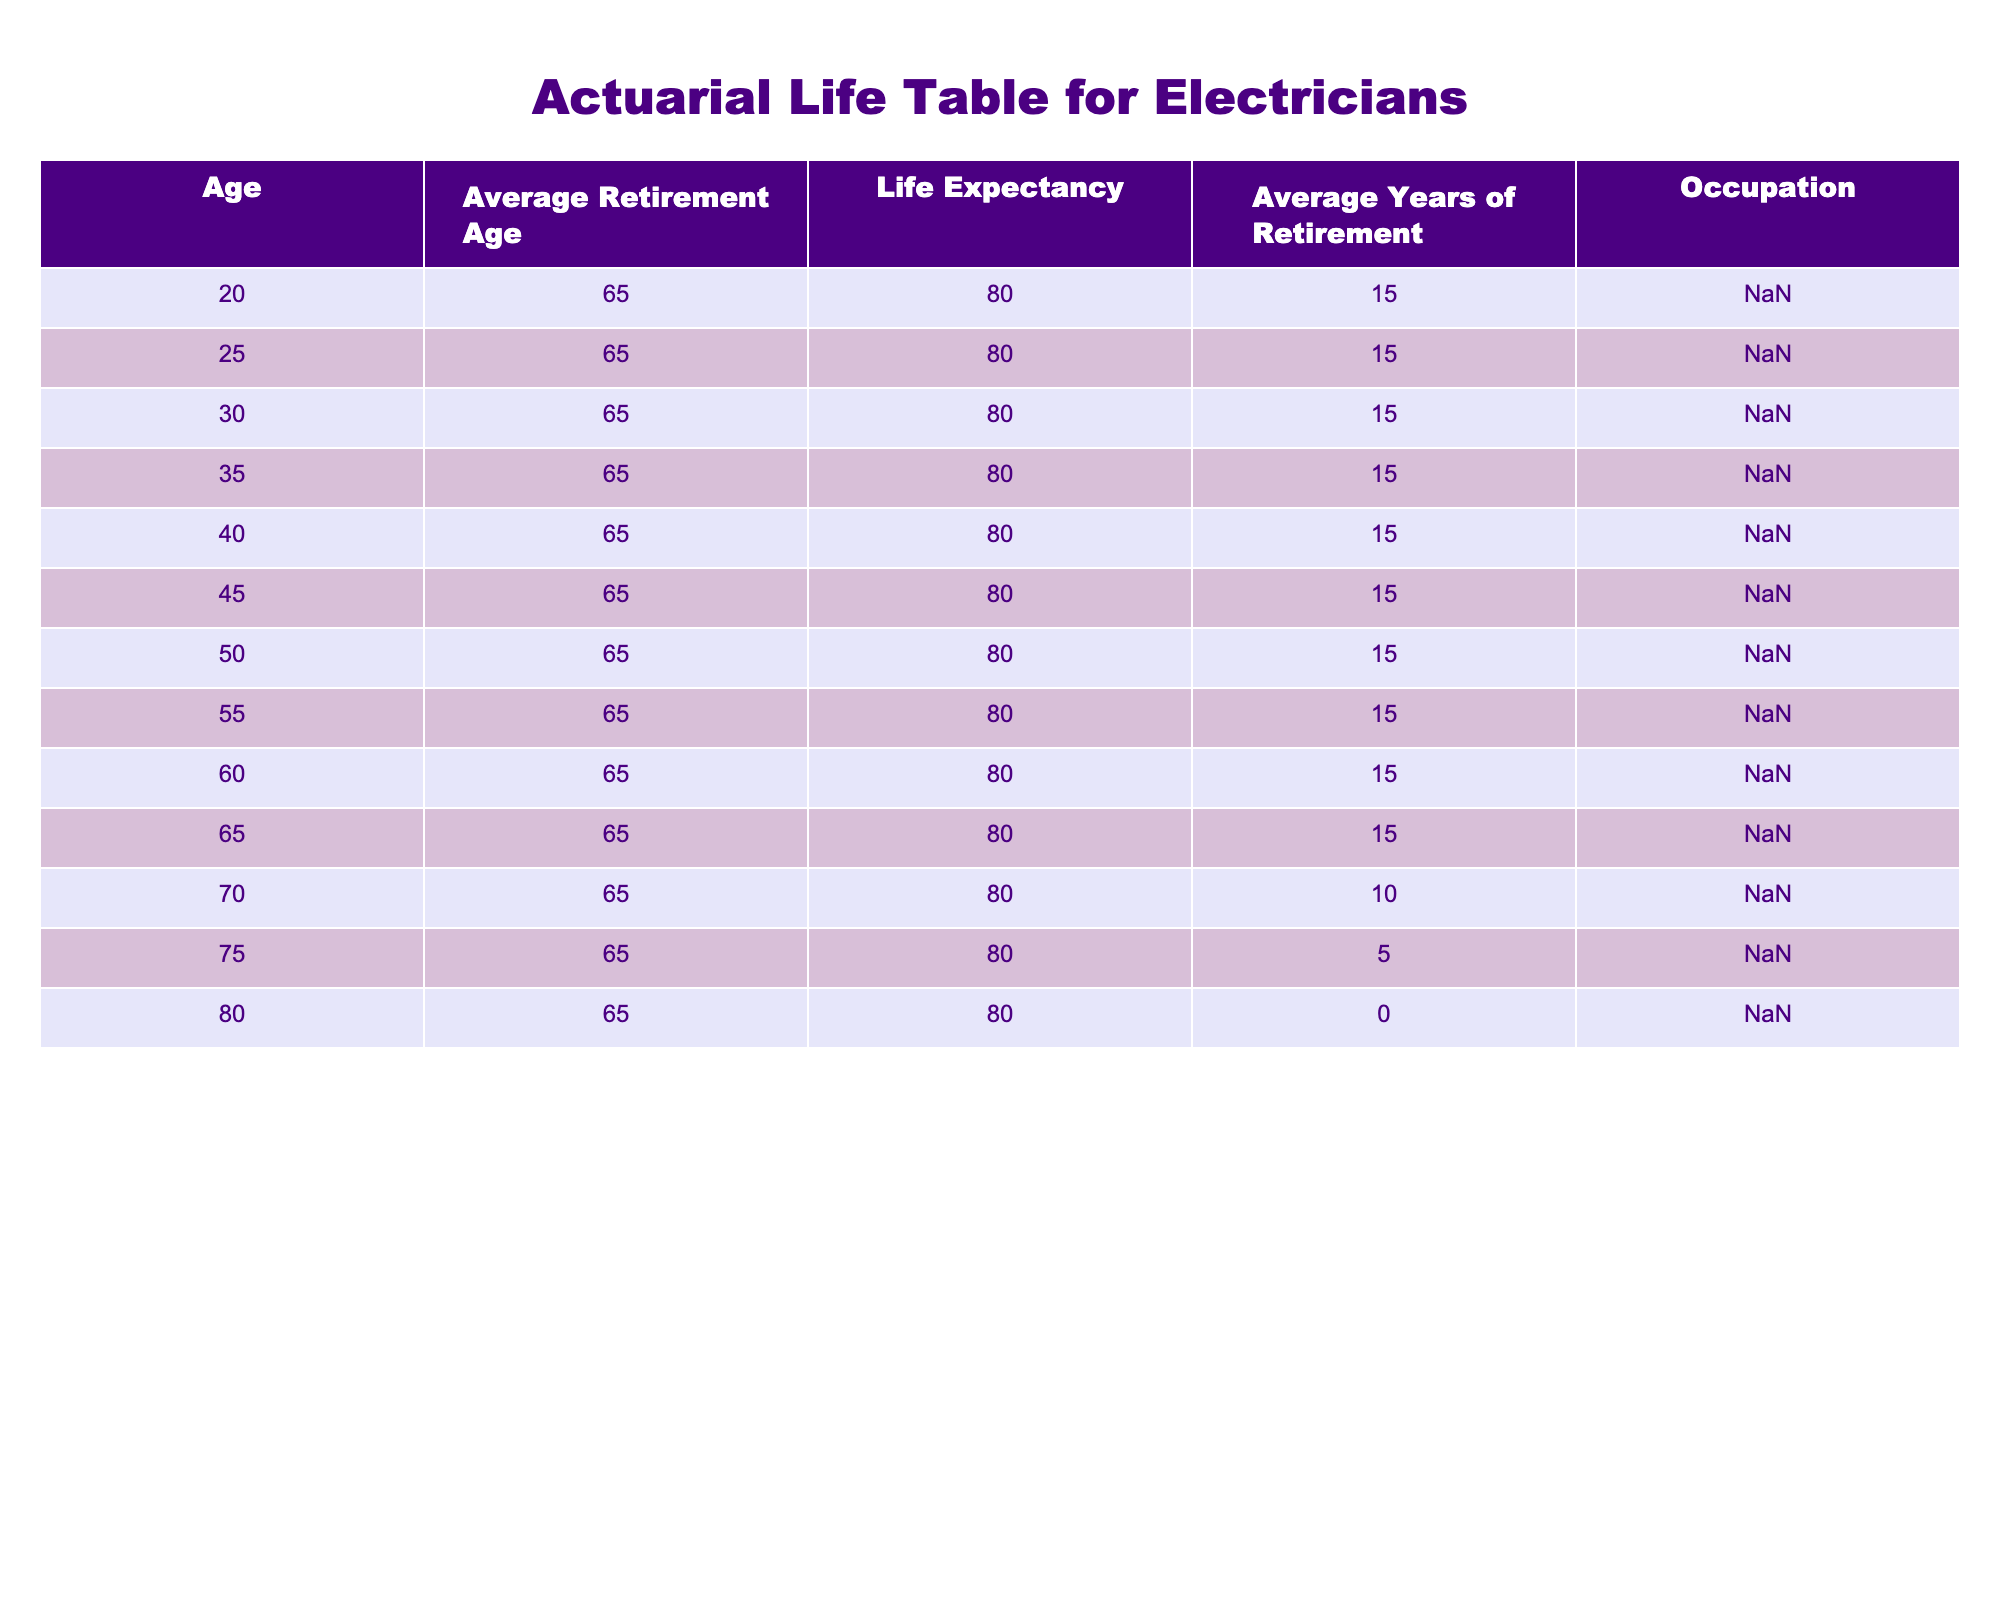What is the average retirement age for electricians? The table indicates that the average retirement age for electricians is consistently 65 across all age entries shown. There are no variations in this value for different age groups.
Answer: 65 What is the life expectancy for electricians? According to the table, the life expectancy for electricians is noted as 80 years for all age groups listed. This value remains the same regardless of age.
Answer: 80 How many years of retirement can an electrician expect if they retire at age 65? The table shows that electricians expect to live for 15 years after retiring at 65, which is under the "Average Years of Retirement" column.
Answer: 15 Is it true that electricians have a shorter average retirement duration as they grow older? Yes, it is true. The table shows that electricians retiring at 70 have an average retirement duration of 10 years, while those retiring at 65 can expect 15 years, indicating a decrease in retirement duration with age.
Answer: Yes What is the difference in average years of retirement between electricians who retire at 65 and those who retire at 75? Electricians retiring at 65 have an average of 15 years of retirement, while those retiring at 75 have only 5 years. The difference is 15 - 5 = 10 years.
Answer: 10 If an electrician is currently 50 years old, what is the total life expectancy remaining after retirement at the average age? If an electrician is 50 now, assuming they retire at 65 (with a life expectancy of 80), they will have 15 years of retirement. After those 15 years, they would live for an additional 15 years (80 - 65), totaling 30 years remaining from their current age.
Answer: 30 For an electrician who retires at age 70, how many years of retirement do they have left compared to those retiring at age 65? Those retiring at age 70 have 10 years of retirement, while those at 65 have 15 years. The difference in retirement years is 15 - 10 = 5 years less for the 70-year-old retiree.
Answer: 5 How many electricians listed in the table have an expected retirement duration of 0 years? The table specifies that electricians who reach age 80 will have an average of 0 years of retirement, meaning they will not have any time left for retirement at that age. There is only one entry with this value.
Answer: 1 What can you conclude about the trend in average years of retirement for electricians as they age from 60 to 80? The trend indicates a decrease in average years of retirement as electricians age. At 60, the expected retirement years are still 15, but by age 70 it drops to 10, and by age 80, it is 0 years. This shows a declining trend.
Answer: Declining trend 